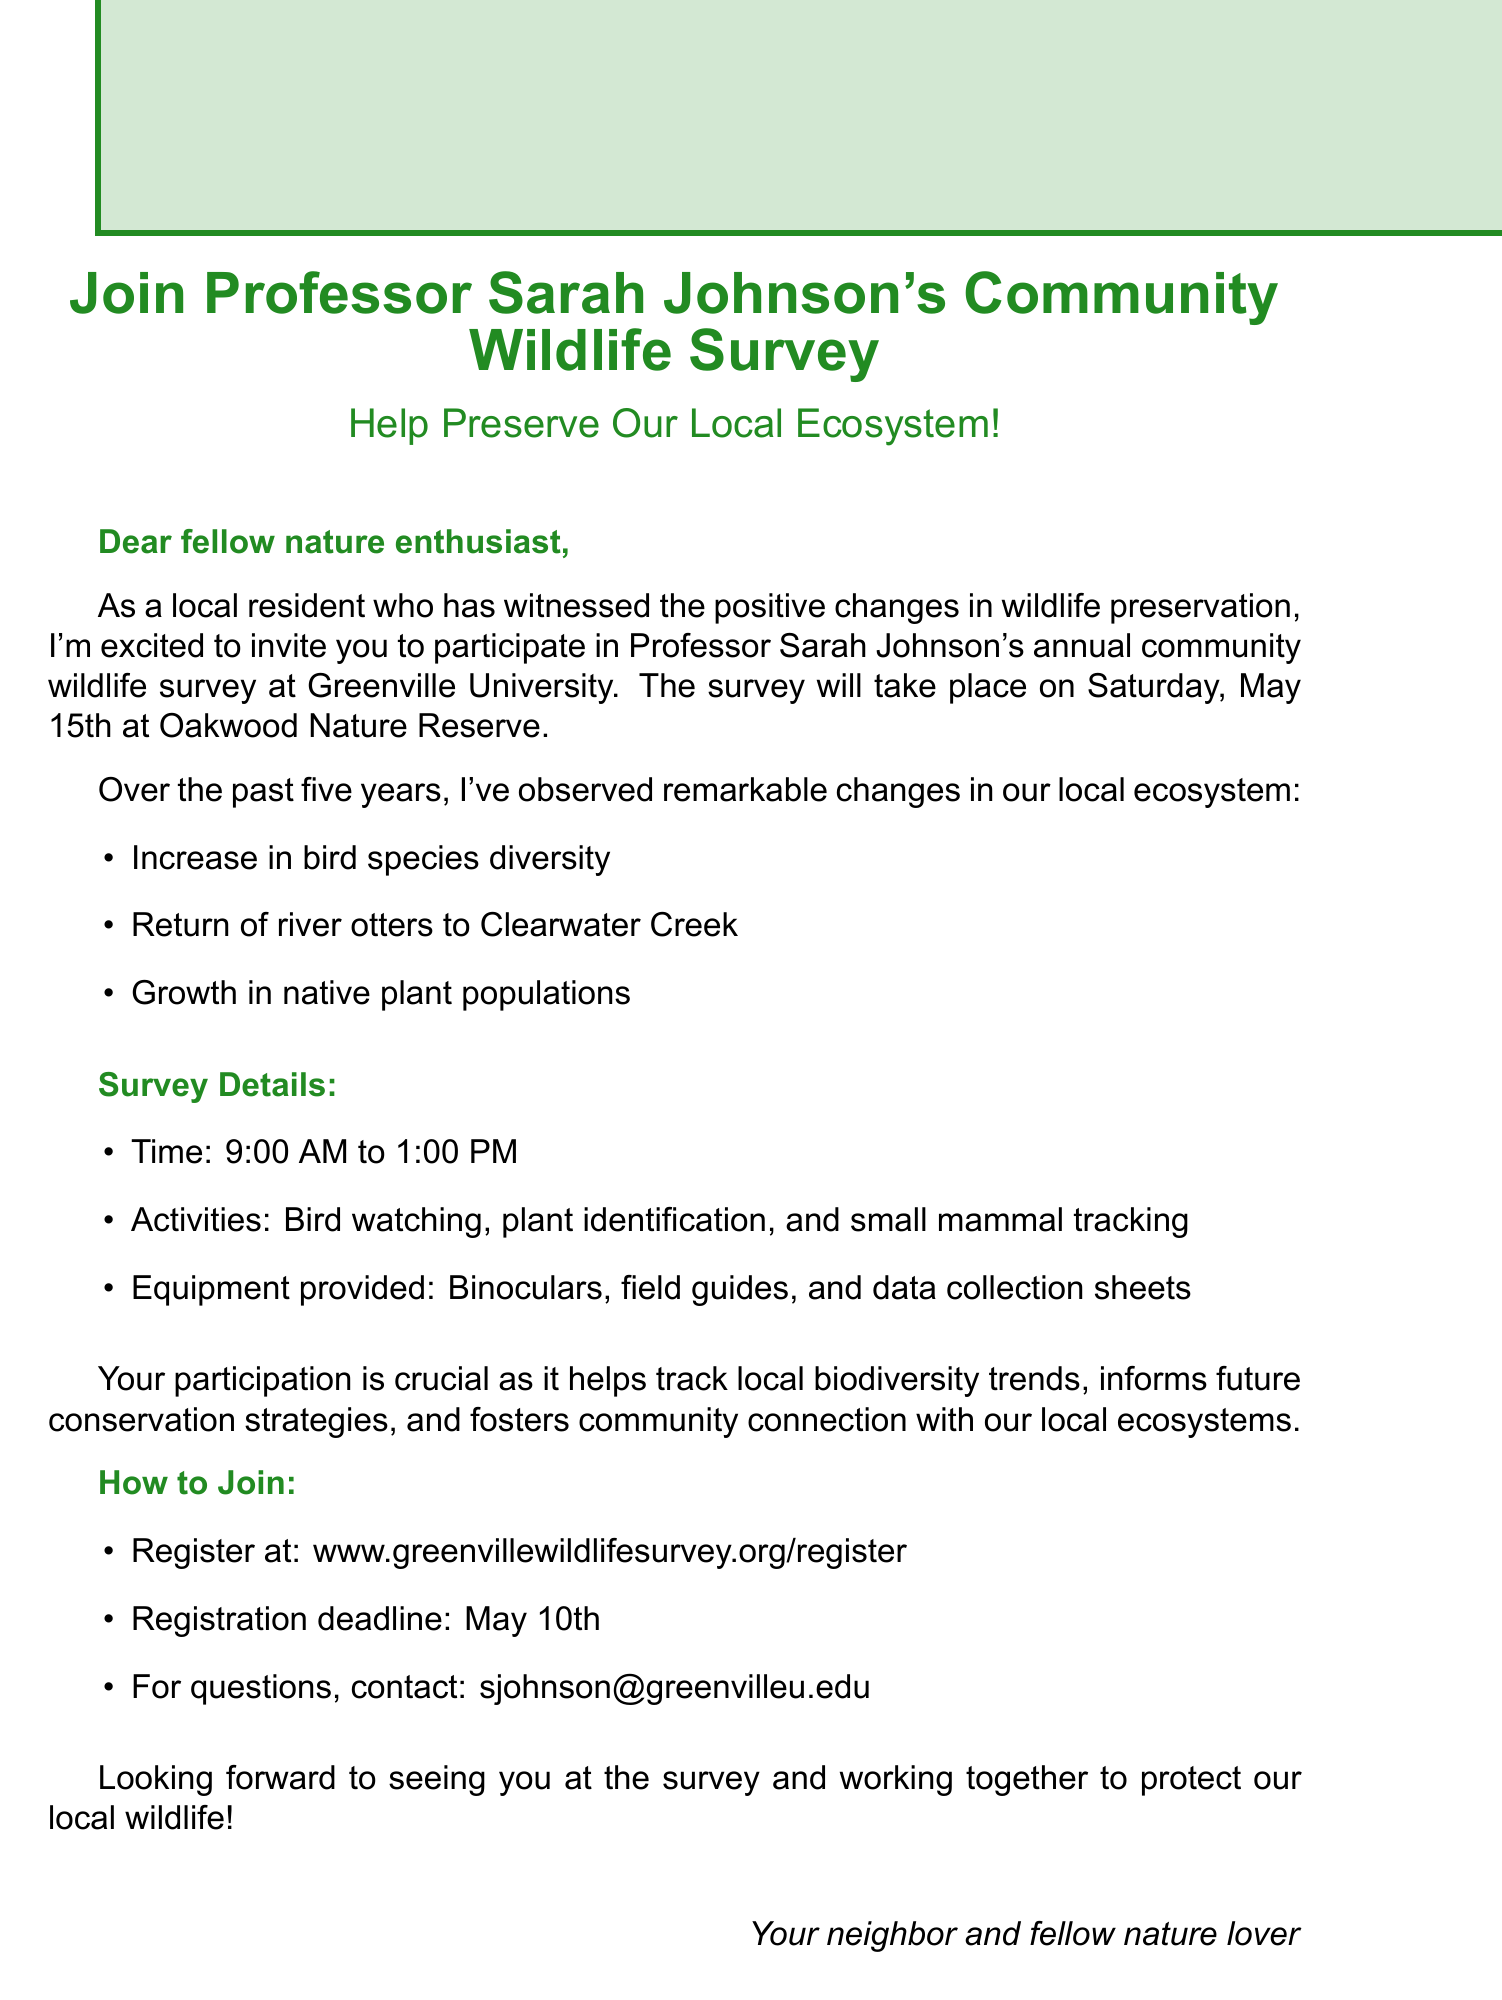What is the name of the professor organizing the survey? The document states that the survey is organized by Professor Sarah Johnson.
Answer: Professor Sarah Johnson What is the date of the wildlife survey? The document mentions that the survey will take place on Saturday, May 15th.
Answer: Saturday, May 15th What is the location of the meeting point for the survey? According to the document, the meeting point for the survey is Oakwood Nature Reserve.
Answer: Oakwood Nature Reserve What activities are included in the survey? The document lists bird watching, plant identification, and small mammal tracking as activities for the survey.
Answer: Bird watching, plant identification, small mammal tracking What equipment will be provided during the survey? The document specifies that binoculars, field guides, and data collection sheets will be provided.
Answer: Binoculars, field guides, data collection sheets How long is the duration of the survey? The document states that the survey will last from 9:00 AM to 1:00 PM.
Answer: 9:00 AM to 1:00 PM What is one observed change in the local wildlife over the past five years? The document notes an increase in bird species diversity as one of the observed changes.
Answer: Increase in bird species diversity What is the registration deadline for the survey? The document indicates that the registration deadline is May 10th.
Answer: May 10th How can participants register for the survey? According to the document, participants can register at www.greenvillewildlifesurvey.org/register.
Answer: www.greenvillewildlifesurvey.org/register 